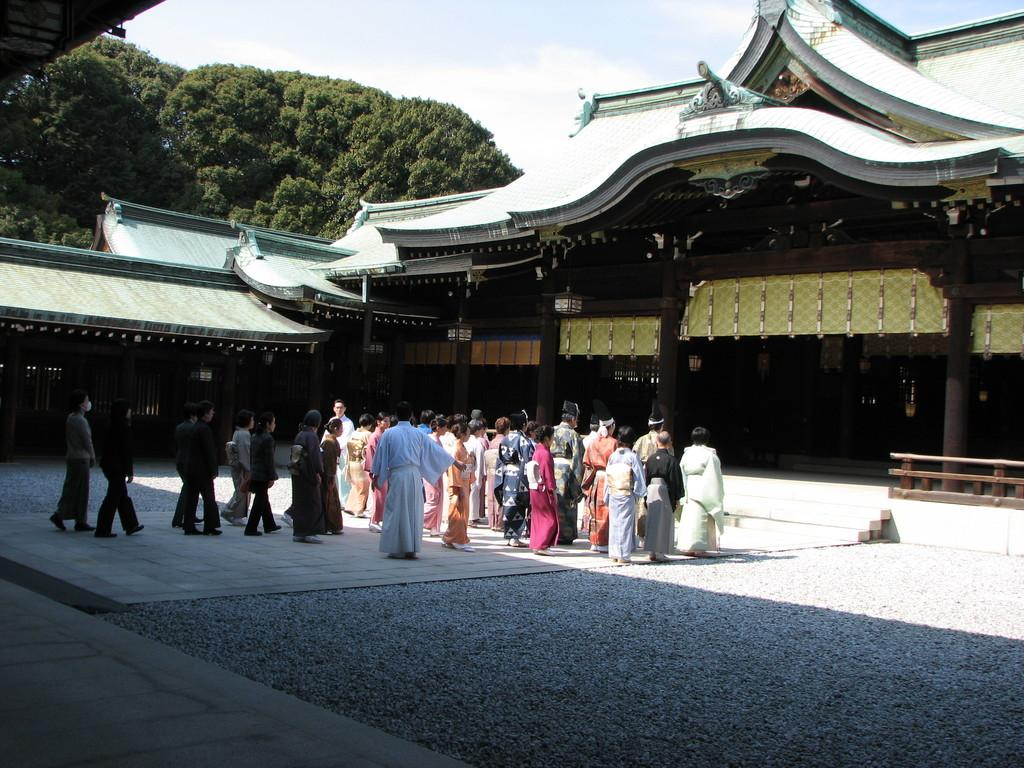What type of structure is present in the image? There is a building in the image. Who or what can be seen near the building? There is a group of people in the image. What architectural features are visible on the building? There are pillars in the image. Are there any lighting elements in the image? Yes, there are lights in the image. What type of vegetation is present in the image? There are trees in the image. Are there any accessibility features in the image? Yes, there are stairs in the image. What can be seen in the distance in the image? The sky is visible in the background of the image. What type of worm can be seen crawling on the building in the image? There are no worms present in the image; it features a building with a group of people, pillars, lights, trees, stairs, and a visible sky in the background. 